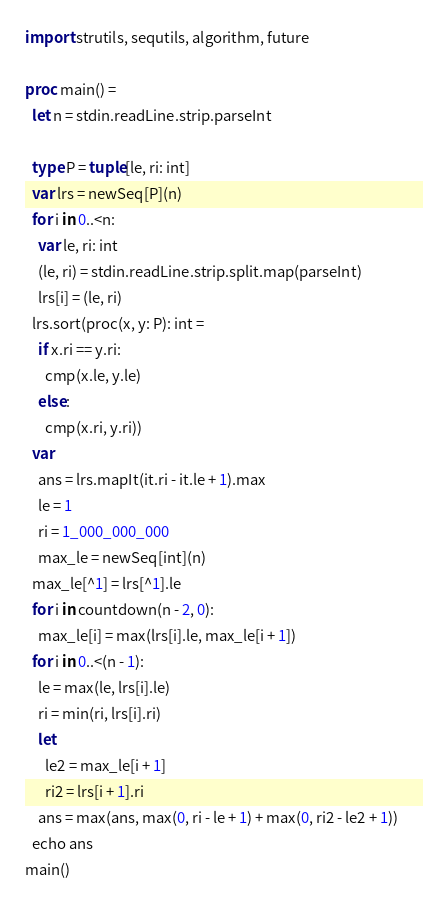<code> <loc_0><loc_0><loc_500><loc_500><_Nim_>import strutils, sequtils, algorithm, future

proc main() =
  let n = stdin.readLine.strip.parseInt

  type P = tuple[le, ri: int]
  var lrs = newSeq[P](n)
  for i in 0..<n:
    var le, ri: int
    (le, ri) = stdin.readLine.strip.split.map(parseInt)
    lrs[i] = (le, ri)
  lrs.sort(proc(x, y: P): int =
    if x.ri == y.ri:
      cmp(x.le, y.le)
    else:
      cmp(x.ri, y.ri))
  var
    ans = lrs.mapIt(it.ri - it.le + 1).max
    le = 1
    ri = 1_000_000_000
    max_le = newSeq[int](n)
  max_le[^1] = lrs[^1].le
  for i in countdown(n - 2, 0):
    max_le[i] = max(lrs[i].le, max_le[i + 1])
  for i in 0..<(n - 1):
    le = max(le, lrs[i].le)
    ri = min(ri, lrs[i].ri)
    let
      le2 = max_le[i + 1]
      ri2 = lrs[i + 1].ri
    ans = max(ans, max(0, ri - le + 1) + max(0, ri2 - le2 + 1))
  echo ans
main()
</code> 